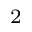<formula> <loc_0><loc_0><loc_500><loc_500>^ { 2 }</formula> 